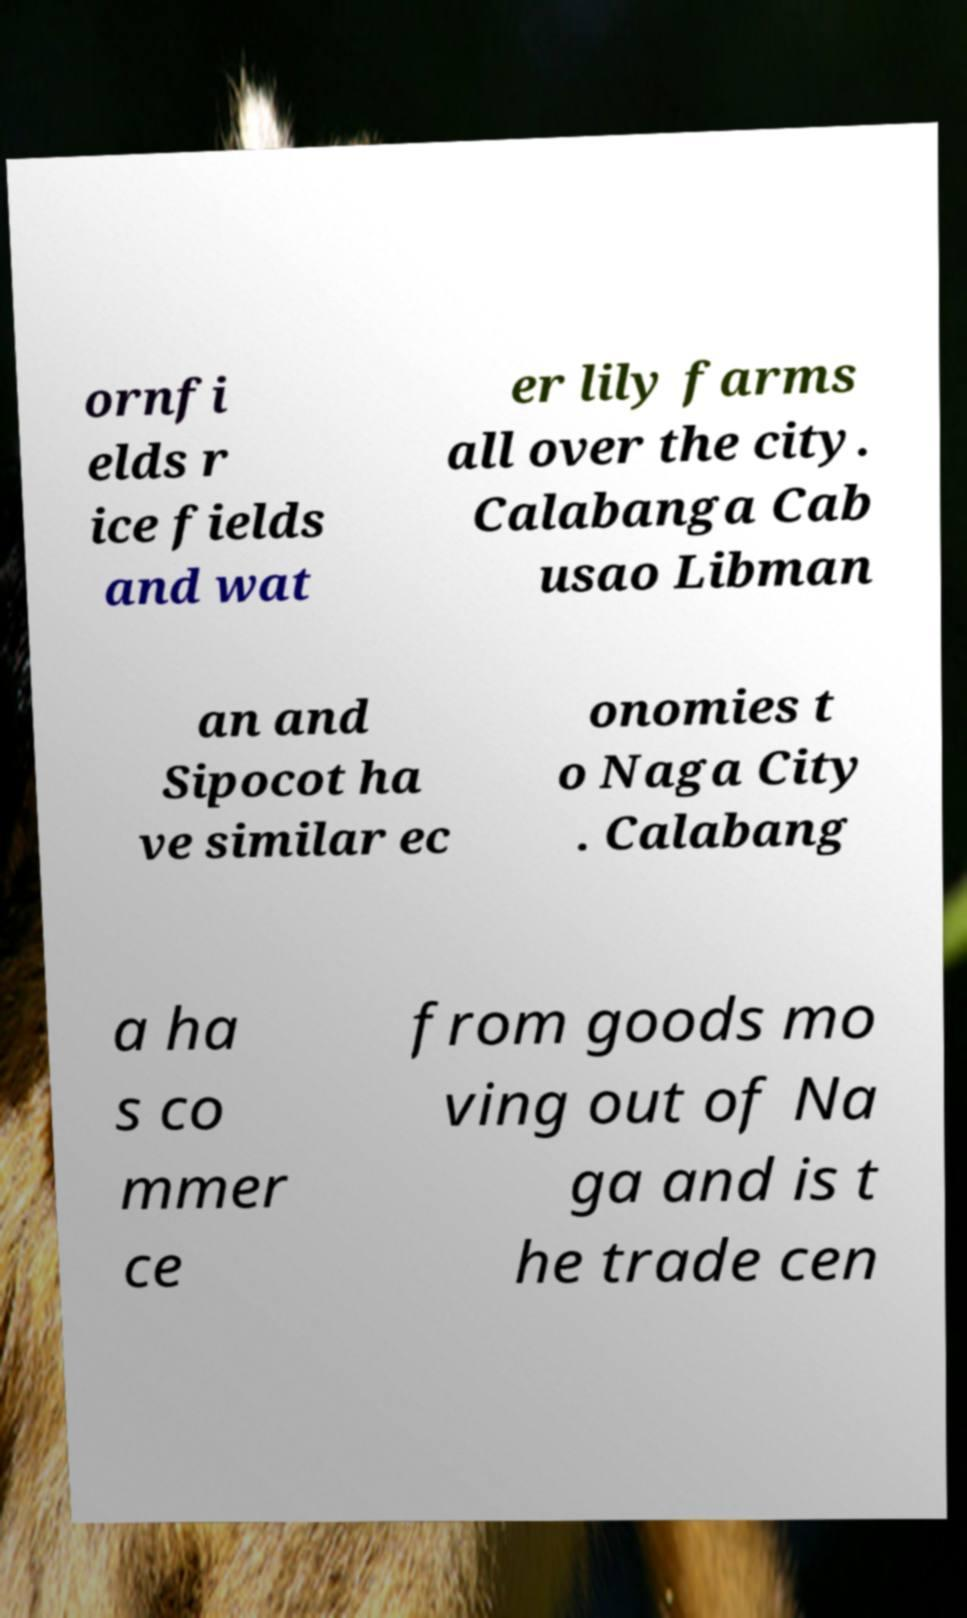Could you assist in decoding the text presented in this image and type it out clearly? ornfi elds r ice fields and wat er lily farms all over the city. Calabanga Cab usao Libman an and Sipocot ha ve similar ec onomies t o Naga City . Calabang a ha s co mmer ce from goods mo ving out of Na ga and is t he trade cen 